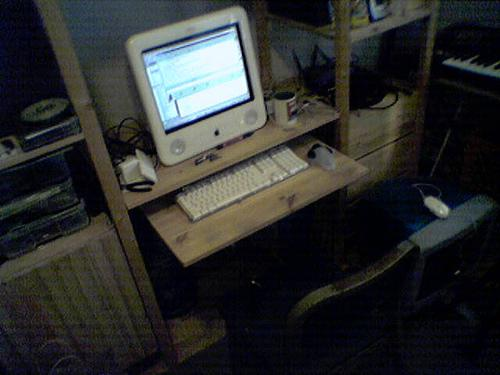Question: what is in front of the computer?
Choices:
A. A mouse.
B. A pen.
C. A tablet.
D. A keyboard.
Answer with the letter. Answer: D Question: how is the lighting?
Choices:
A. Bright.
B. Dark.
C. Yellowish.
D. Dim.
Answer with the letter. Answer: D Question: why it is the computer lit?
Choices:
A. It is charging.
B. It is working.
C. It is resetting.
D. It is on.
Answer with the letter. Answer: D Question: what is in the office?
Choices:
A. A computer.
B. Desk.
C. Pencil.
D. Paper.
Answer with the letter. Answer: A Question: where is this picture taken?
Choices:
A. In the room.
B. In the kitchen.
C. In the office.
D. In the living room.
Answer with the letter. Answer: C 